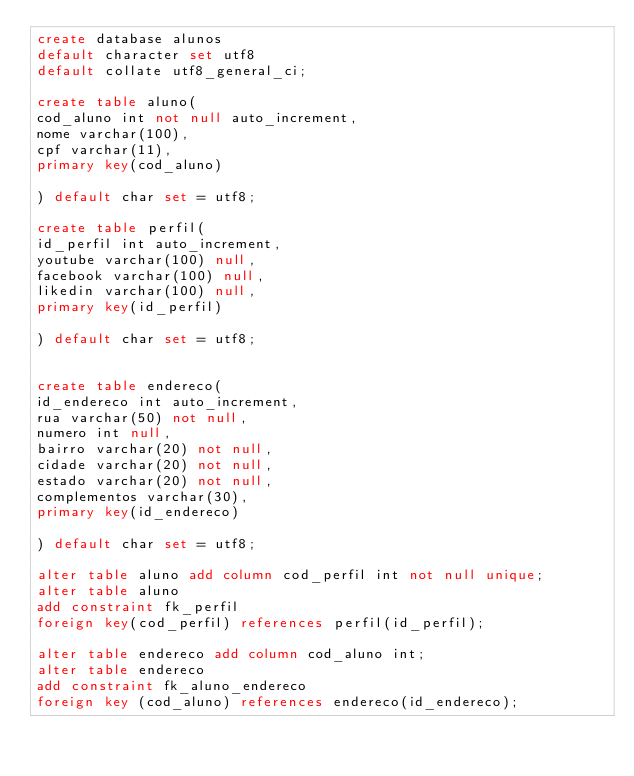Convert code to text. <code><loc_0><loc_0><loc_500><loc_500><_SQL_>create database alunos
default character set utf8
default collate utf8_general_ci;

create table aluno(
cod_aluno int not null auto_increment,
nome varchar(100),
cpf varchar(11),
primary key(cod_aluno)

) default char set = utf8;

create table perfil(
id_perfil int auto_increment,
youtube varchar(100) null,
facebook varchar(100) null,
likedin varchar(100) null,
primary key(id_perfil)

) default char set = utf8;


create table endereco(
id_endereco int auto_increment,
rua varchar(50) not null,
numero int null,
bairro varchar(20) not null,
cidade varchar(20) not null,
estado varchar(20) not null,
complementos varchar(30),
primary key(id_endereco)

) default char set = utf8;

alter table aluno add column cod_perfil int not null unique;
alter table aluno 
add constraint fk_perfil 
foreign key(cod_perfil) references perfil(id_perfil);

alter table endereco add column cod_aluno int;
alter table endereco 
add constraint fk_aluno_endereco 
foreign key (cod_aluno) references endereco(id_endereco);

</code> 